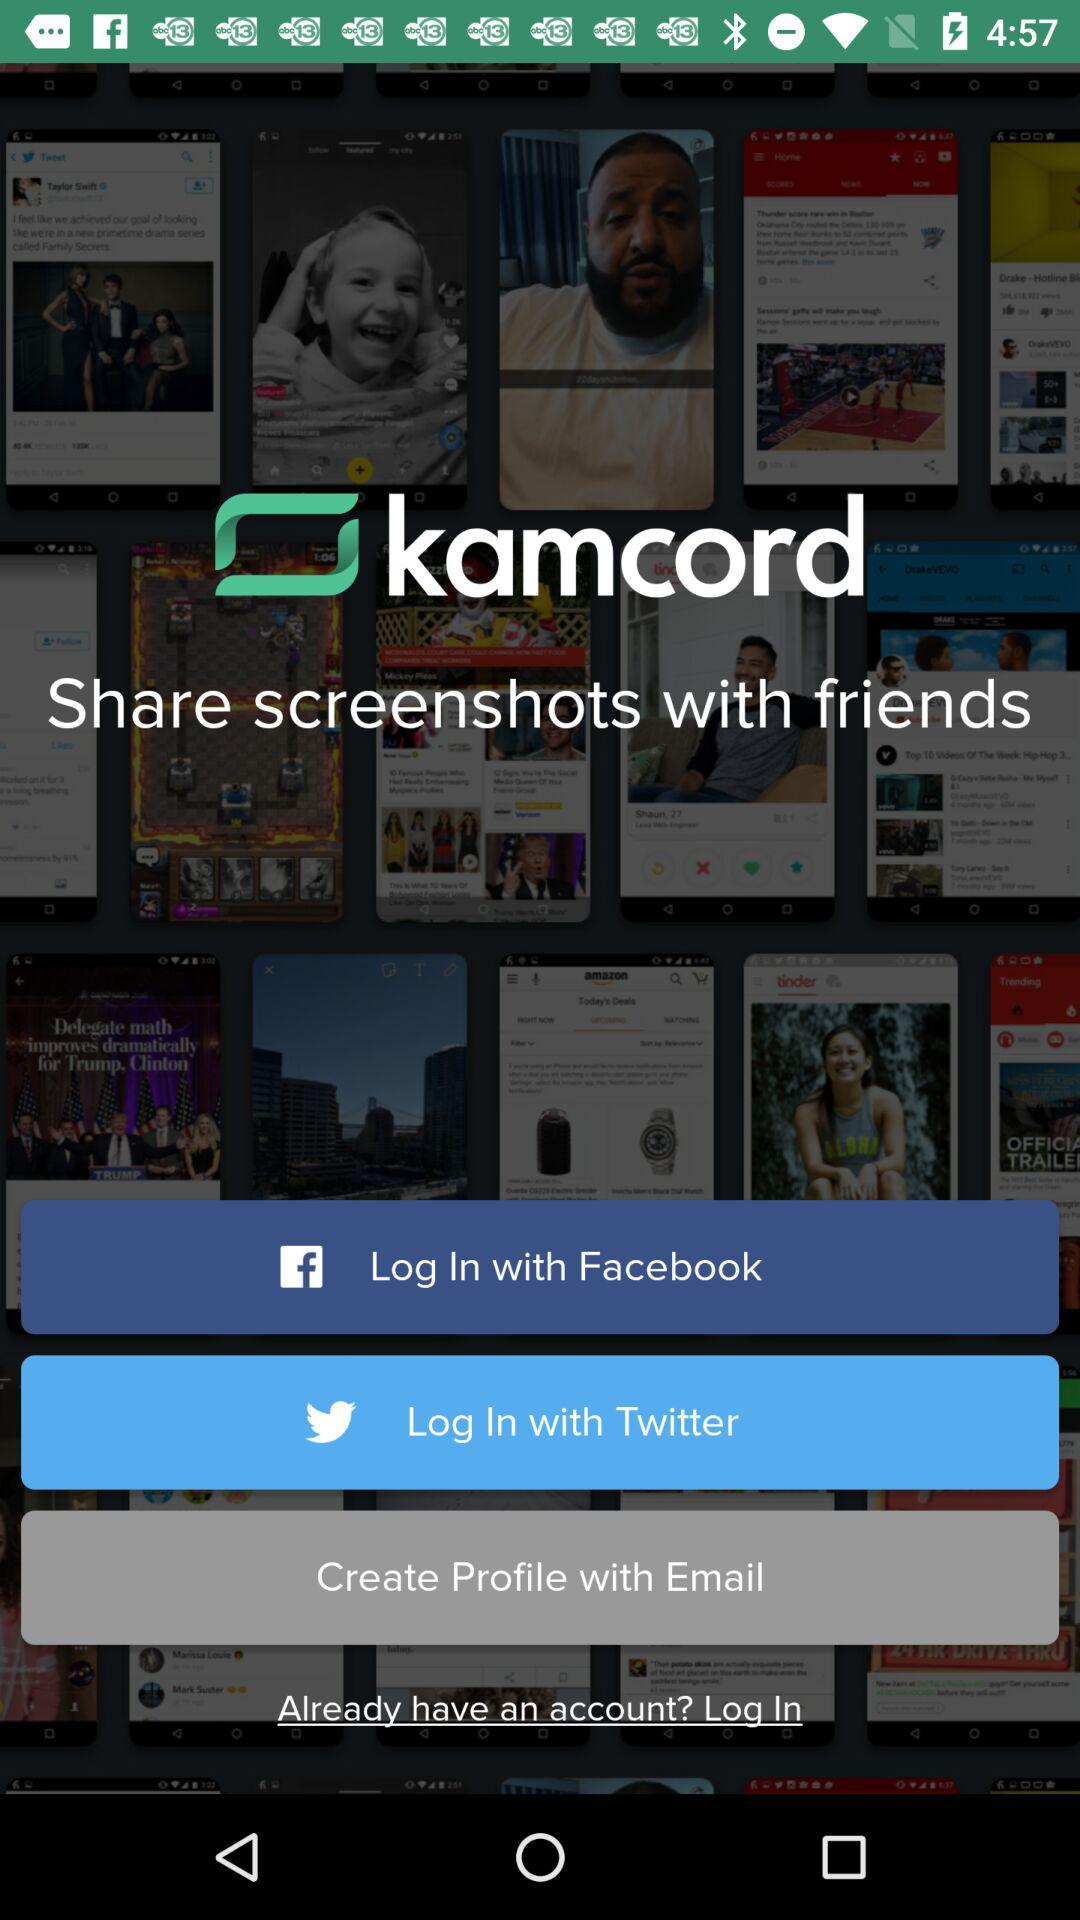What's the application name? The application name is "kamcord". 